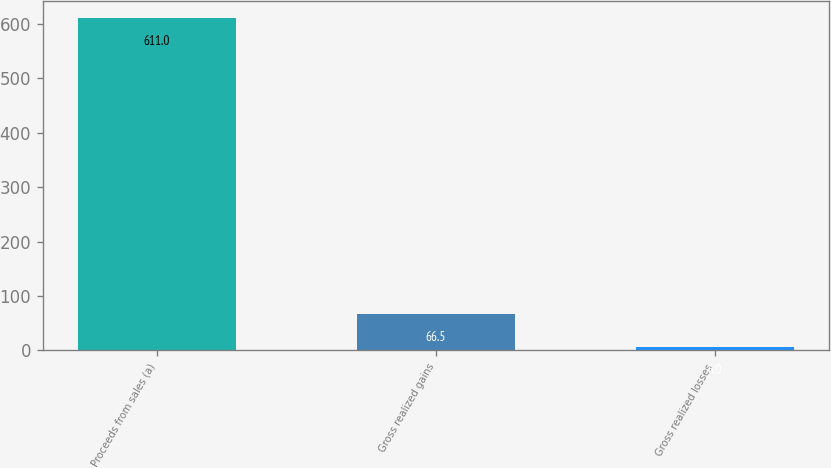Convert chart to OTSL. <chart><loc_0><loc_0><loc_500><loc_500><bar_chart><fcel>Proceeds from sales (a)<fcel>Gross realized gains<fcel>Gross realized losses<nl><fcel>611<fcel>66.5<fcel>6<nl></chart> 